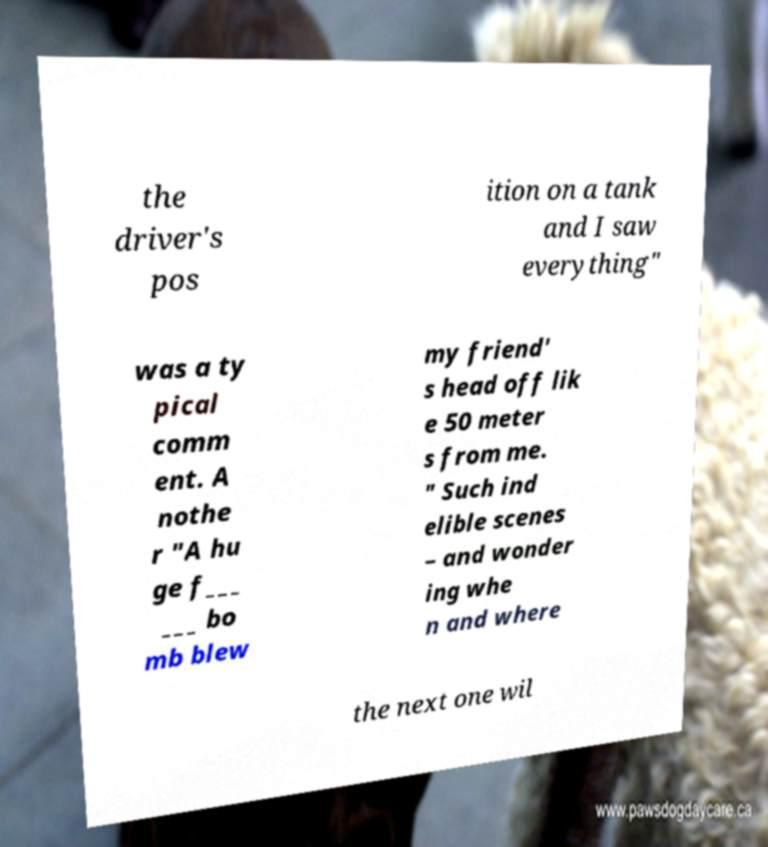Please identify and transcribe the text found in this image. the driver's pos ition on a tank and I saw everything" was a ty pical comm ent. A nothe r "A hu ge f___ ___ bo mb blew my friend' s head off lik e 50 meter s from me. " Such ind elible scenes – and wonder ing whe n and where the next one wil 